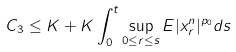Convert formula to latex. <formula><loc_0><loc_0><loc_500><loc_500>C _ { 3 } \leq K + K \int _ { 0 } ^ { t } \sup _ { 0 \leq r \leq s } E | x _ { r } ^ { n } | ^ { p _ { 0 } } d s</formula> 